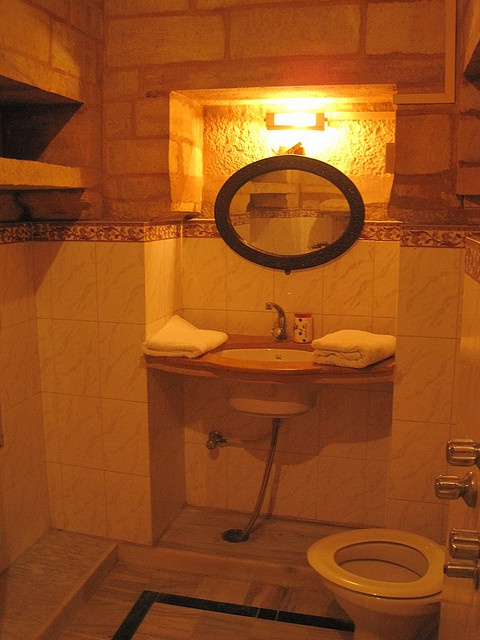Describe the objects in this image and their specific colors. I can see toilet in brown, maroon, and black tones, sink in brown, red, and maroon tones, and cup in brown, red, and maroon tones in this image. 